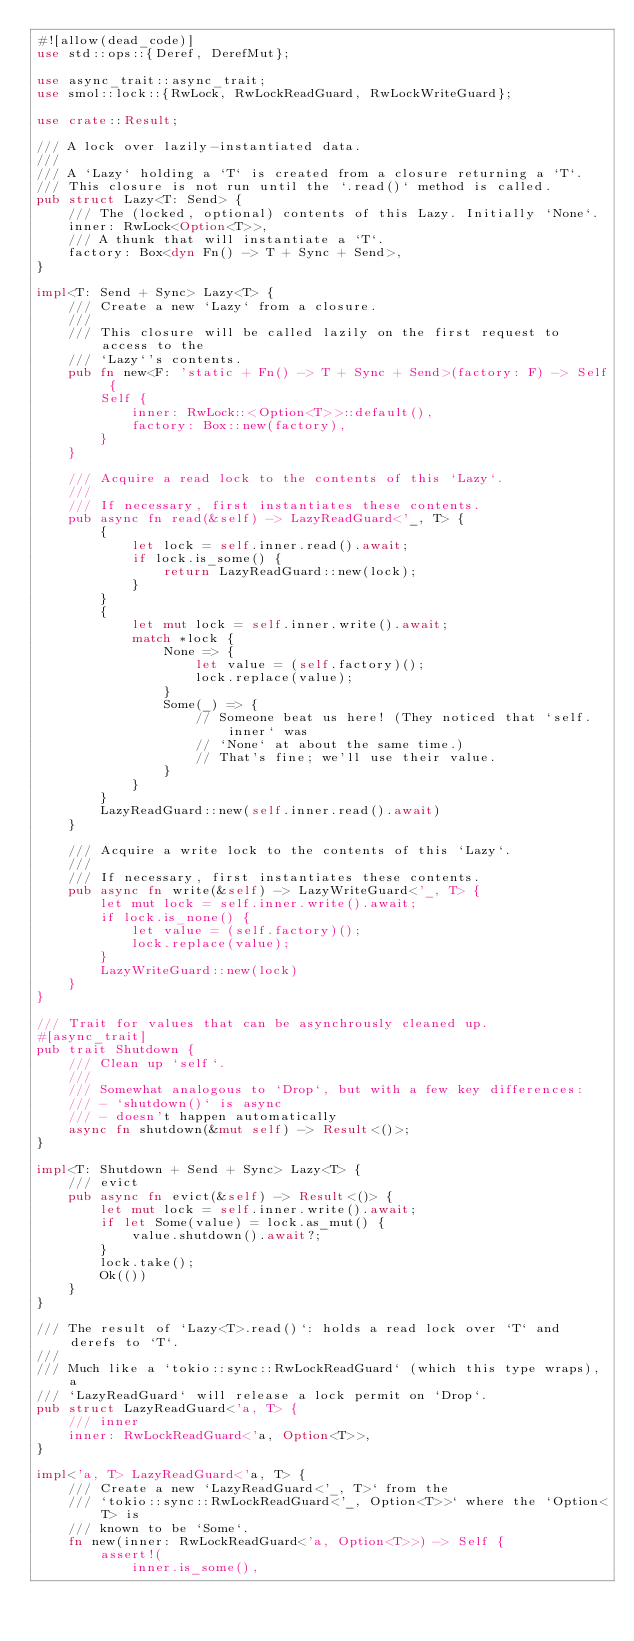Convert code to text. <code><loc_0><loc_0><loc_500><loc_500><_Rust_>#![allow(dead_code)]
use std::ops::{Deref, DerefMut};

use async_trait::async_trait;
use smol::lock::{RwLock, RwLockReadGuard, RwLockWriteGuard};

use crate::Result;

/// A lock over lazily-instantiated data.
///
/// A `Lazy` holding a `T` is created from a closure returning a `T`.
/// This closure is not run until the `.read()` method is called.
pub struct Lazy<T: Send> {
    /// The (locked, optional) contents of this Lazy. Initially `None`.
    inner: RwLock<Option<T>>,
    /// A thunk that will instantiate a `T`.
    factory: Box<dyn Fn() -> T + Sync + Send>,
}

impl<T: Send + Sync> Lazy<T> {
    /// Create a new `Lazy` from a closure.
    ///
    /// This closure will be called lazily on the first request to access to the
    /// `Lazy`'s contents.
    pub fn new<F: 'static + Fn() -> T + Sync + Send>(factory: F) -> Self {
        Self {
            inner: RwLock::<Option<T>>::default(),
            factory: Box::new(factory),
        }
    }

    /// Acquire a read lock to the contents of this `Lazy`.
    ///
    /// If necessary, first instantiates these contents.
    pub async fn read(&self) -> LazyReadGuard<'_, T> {
        {
            let lock = self.inner.read().await;
            if lock.is_some() {
                return LazyReadGuard::new(lock);
            }
        }
        {
            let mut lock = self.inner.write().await;
            match *lock {
                None => {
                    let value = (self.factory)();
                    lock.replace(value);
                }
                Some(_) => {
                    // Someone beat us here! (They noticed that `self.inner` was
                    // `None` at about the same time.)
                    // That's fine; we'll use their value.
                }
            }
        }
        LazyReadGuard::new(self.inner.read().await)
    }

    /// Acquire a write lock to the contents of this `Lazy`.
    ///
    /// If necessary, first instantiates these contents.
    pub async fn write(&self) -> LazyWriteGuard<'_, T> {
        let mut lock = self.inner.write().await;
        if lock.is_none() {
            let value = (self.factory)();
            lock.replace(value);
        }
        LazyWriteGuard::new(lock)
    }
}

/// Trait for values that can be asynchrously cleaned up.
#[async_trait]
pub trait Shutdown {
    /// Clean up `self`.
    ///
    /// Somewhat analogous to `Drop`, but with a few key differences:
    /// - `shutdown()` is async
    /// - doesn't happen automatically
    async fn shutdown(&mut self) -> Result<()>;
}

impl<T: Shutdown + Send + Sync> Lazy<T> {
    /// evict
    pub async fn evict(&self) -> Result<()> {
        let mut lock = self.inner.write().await;
        if let Some(value) = lock.as_mut() {
            value.shutdown().await?;
        }
        lock.take();
        Ok(())
    }
}

/// The result of `Lazy<T>.read()`: holds a read lock over `T` and derefs to `T`.
///
/// Much like a `tokio::sync::RwLockReadGuard` (which this type wraps), a
/// `LazyReadGuard` will release a lock permit on `Drop`.
pub struct LazyReadGuard<'a, T> {
    /// inner
    inner: RwLockReadGuard<'a, Option<T>>,
}

impl<'a, T> LazyReadGuard<'a, T> {
    /// Create a new `LazyReadGuard<'_, T>` from the
    /// `tokio::sync::RwLockReadGuard<'_, Option<T>>` where the `Option<T> is
    /// known to be `Some`.
    fn new(inner: RwLockReadGuard<'a, Option<T>>) -> Self {
        assert!(
            inner.is_some(),</code> 